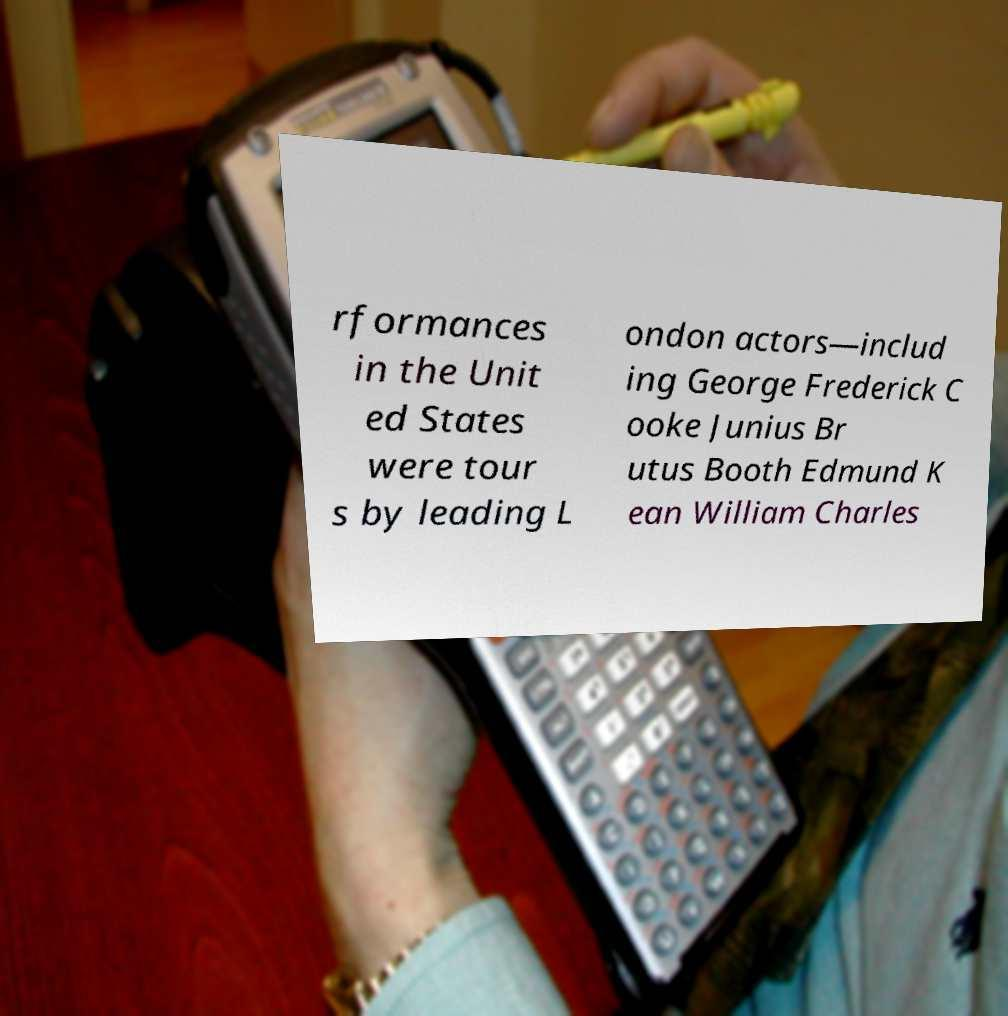I need the written content from this picture converted into text. Can you do that? rformances in the Unit ed States were tour s by leading L ondon actors—includ ing George Frederick C ooke Junius Br utus Booth Edmund K ean William Charles 